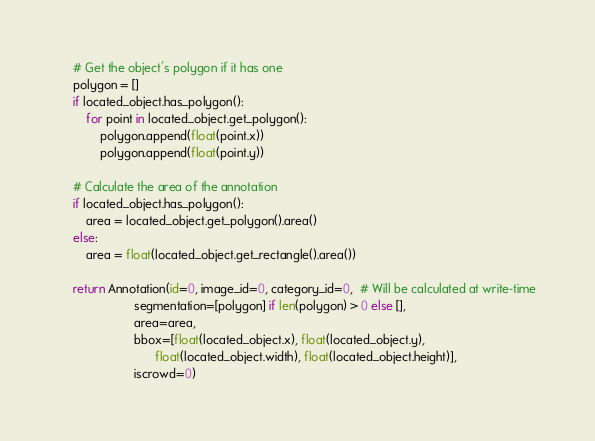<code> <loc_0><loc_0><loc_500><loc_500><_Python_>    # Get the object's polygon if it has one
    polygon = []
    if located_object.has_polygon():
        for point in located_object.get_polygon():
            polygon.append(float(point.x))
            polygon.append(float(point.y))

    # Calculate the area of the annotation
    if located_object.has_polygon():
        area = located_object.get_polygon().area()
    else:
        area = float(located_object.get_rectangle().area())

    return Annotation(id=0, image_id=0, category_id=0,  # Will be calculated at write-time
                      segmentation=[polygon] if len(polygon) > 0 else [],
                      area=area,
                      bbox=[float(located_object.x), float(located_object.y),
                            float(located_object.width), float(located_object.height)],
                      iscrowd=0)
</code> 